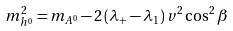Convert formula to latex. <formula><loc_0><loc_0><loc_500><loc_500>m _ { h ^ { 0 } } ^ { 2 } = m _ { A ^ { 0 } } - 2 \left ( \lambda _ { + } - \lambda _ { 1 } \right ) v ^ { 2 } \cos ^ { 2 } \beta</formula> 